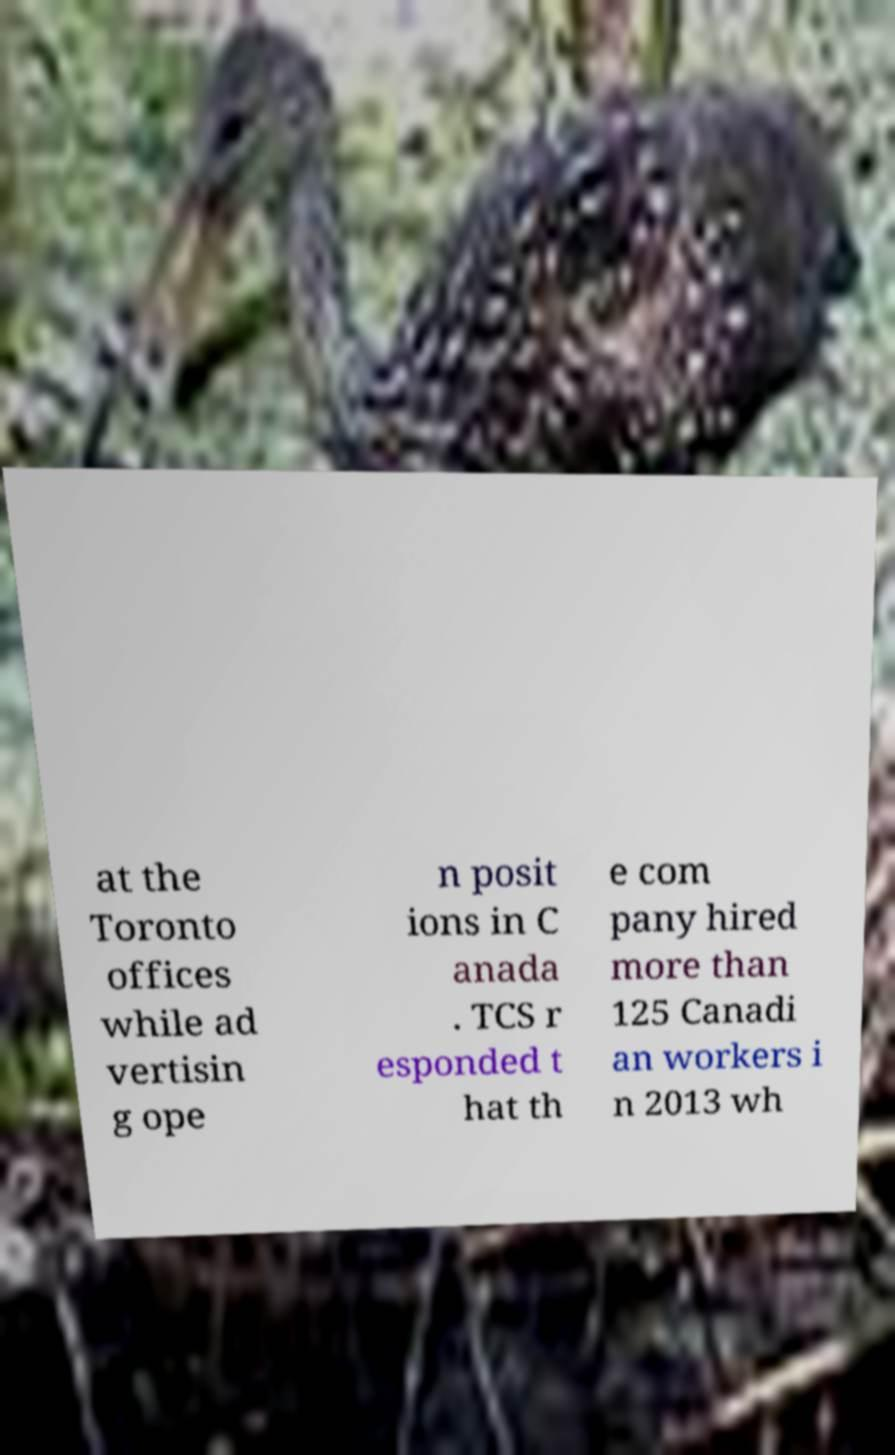Could you assist in decoding the text presented in this image and type it out clearly? at the Toronto offices while ad vertisin g ope n posit ions in C anada . TCS r esponded t hat th e com pany hired more than 125 Canadi an workers i n 2013 wh 